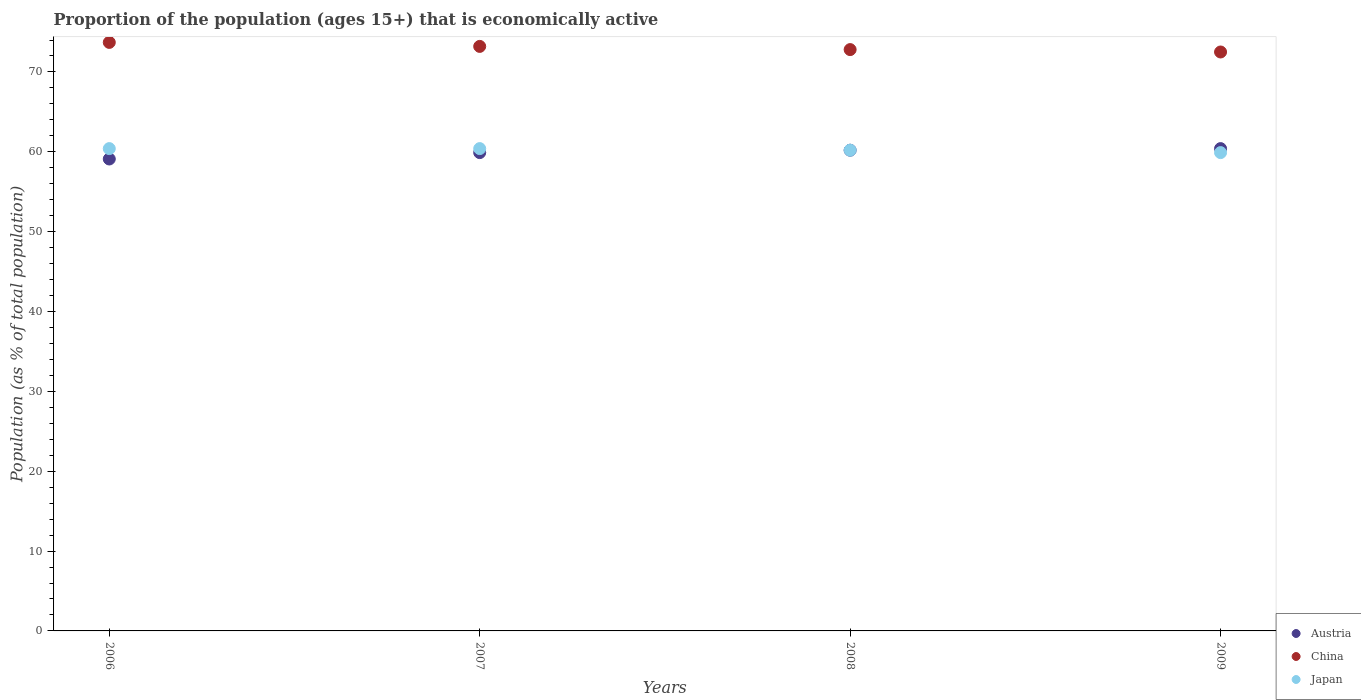Is the number of dotlines equal to the number of legend labels?
Ensure brevity in your answer.  Yes. What is the proportion of the population that is economically active in Austria in 2007?
Ensure brevity in your answer.  59.9. Across all years, what is the maximum proportion of the population that is economically active in Japan?
Provide a short and direct response. 60.4. Across all years, what is the minimum proportion of the population that is economically active in China?
Make the answer very short. 72.5. In which year was the proportion of the population that is economically active in China minimum?
Make the answer very short. 2009. What is the total proportion of the population that is economically active in Japan in the graph?
Your response must be concise. 240.9. What is the difference between the proportion of the population that is economically active in China in 2006 and that in 2009?
Your answer should be very brief. 1.2. What is the difference between the proportion of the population that is economically active in China in 2008 and the proportion of the population that is economically active in Japan in 2007?
Offer a very short reply. 12.4. What is the average proportion of the population that is economically active in Japan per year?
Offer a very short reply. 60.23. In the year 2009, what is the difference between the proportion of the population that is economically active in China and proportion of the population that is economically active in Japan?
Ensure brevity in your answer.  12.6. In how many years, is the proportion of the population that is economically active in China greater than 12 %?
Give a very brief answer. 4. What is the ratio of the proportion of the population that is economically active in Austria in 2008 to that in 2009?
Give a very brief answer. 1. What is the difference between the highest and the second highest proportion of the population that is economically active in China?
Provide a short and direct response. 0.5. In how many years, is the proportion of the population that is economically active in Japan greater than the average proportion of the population that is economically active in Japan taken over all years?
Provide a succinct answer. 2. Is the sum of the proportion of the population that is economically active in Japan in 2008 and 2009 greater than the maximum proportion of the population that is economically active in China across all years?
Provide a short and direct response. Yes. Does the proportion of the population that is economically active in Austria monotonically increase over the years?
Give a very brief answer. Yes. Is the proportion of the population that is economically active in China strictly greater than the proportion of the population that is economically active in Japan over the years?
Keep it short and to the point. Yes. Is the proportion of the population that is economically active in China strictly less than the proportion of the population that is economically active in Austria over the years?
Make the answer very short. No. How many dotlines are there?
Provide a short and direct response. 3. How many years are there in the graph?
Offer a terse response. 4. What is the difference between two consecutive major ticks on the Y-axis?
Make the answer very short. 10. Are the values on the major ticks of Y-axis written in scientific E-notation?
Ensure brevity in your answer.  No. Does the graph contain any zero values?
Keep it short and to the point. No. How are the legend labels stacked?
Your response must be concise. Vertical. What is the title of the graph?
Offer a very short reply. Proportion of the population (ages 15+) that is economically active. What is the label or title of the X-axis?
Offer a very short reply. Years. What is the label or title of the Y-axis?
Ensure brevity in your answer.  Population (as % of total population). What is the Population (as % of total population) in Austria in 2006?
Ensure brevity in your answer.  59.1. What is the Population (as % of total population) in China in 2006?
Make the answer very short. 73.7. What is the Population (as % of total population) in Japan in 2006?
Your answer should be very brief. 60.4. What is the Population (as % of total population) in Austria in 2007?
Your answer should be compact. 59.9. What is the Population (as % of total population) of China in 2007?
Your answer should be very brief. 73.2. What is the Population (as % of total population) in Japan in 2007?
Give a very brief answer. 60.4. What is the Population (as % of total population) in Austria in 2008?
Your answer should be compact. 60.2. What is the Population (as % of total population) in China in 2008?
Keep it short and to the point. 72.8. What is the Population (as % of total population) of Japan in 2008?
Give a very brief answer. 60.2. What is the Population (as % of total population) in Austria in 2009?
Provide a succinct answer. 60.4. What is the Population (as % of total population) in China in 2009?
Provide a short and direct response. 72.5. What is the Population (as % of total population) of Japan in 2009?
Provide a short and direct response. 59.9. Across all years, what is the maximum Population (as % of total population) of Austria?
Keep it short and to the point. 60.4. Across all years, what is the maximum Population (as % of total population) of China?
Your answer should be very brief. 73.7. Across all years, what is the maximum Population (as % of total population) in Japan?
Your response must be concise. 60.4. Across all years, what is the minimum Population (as % of total population) in Austria?
Your answer should be very brief. 59.1. Across all years, what is the minimum Population (as % of total population) in China?
Offer a terse response. 72.5. Across all years, what is the minimum Population (as % of total population) of Japan?
Offer a terse response. 59.9. What is the total Population (as % of total population) of Austria in the graph?
Ensure brevity in your answer.  239.6. What is the total Population (as % of total population) in China in the graph?
Provide a short and direct response. 292.2. What is the total Population (as % of total population) of Japan in the graph?
Make the answer very short. 240.9. What is the difference between the Population (as % of total population) in China in 2006 and that in 2007?
Offer a very short reply. 0.5. What is the difference between the Population (as % of total population) in Japan in 2006 and that in 2009?
Ensure brevity in your answer.  0.5. What is the difference between the Population (as % of total population) of China in 2007 and that in 2008?
Your response must be concise. 0.4. What is the difference between the Population (as % of total population) of Japan in 2007 and that in 2008?
Provide a short and direct response. 0.2. What is the difference between the Population (as % of total population) of Austria in 2007 and that in 2009?
Ensure brevity in your answer.  -0.5. What is the difference between the Population (as % of total population) of Japan in 2007 and that in 2009?
Keep it short and to the point. 0.5. What is the difference between the Population (as % of total population) of Austria in 2006 and the Population (as % of total population) of China in 2007?
Your response must be concise. -14.1. What is the difference between the Population (as % of total population) in Austria in 2006 and the Population (as % of total population) in Japan in 2007?
Give a very brief answer. -1.3. What is the difference between the Population (as % of total population) in Austria in 2006 and the Population (as % of total population) in China in 2008?
Offer a very short reply. -13.7. What is the difference between the Population (as % of total population) in China in 2006 and the Population (as % of total population) in Japan in 2008?
Your answer should be very brief. 13.5. What is the difference between the Population (as % of total population) in Austria in 2006 and the Population (as % of total population) in China in 2009?
Keep it short and to the point. -13.4. What is the difference between the Population (as % of total population) in China in 2006 and the Population (as % of total population) in Japan in 2009?
Make the answer very short. 13.8. What is the difference between the Population (as % of total population) of Austria in 2007 and the Population (as % of total population) of China in 2008?
Ensure brevity in your answer.  -12.9. What is the difference between the Population (as % of total population) in Austria in 2007 and the Population (as % of total population) in Japan in 2008?
Keep it short and to the point. -0.3. What is the difference between the Population (as % of total population) in Austria in 2007 and the Population (as % of total population) in Japan in 2009?
Provide a succinct answer. 0. What is the difference between the Population (as % of total population) in China in 2007 and the Population (as % of total population) in Japan in 2009?
Your response must be concise. 13.3. What is the average Population (as % of total population) in Austria per year?
Ensure brevity in your answer.  59.9. What is the average Population (as % of total population) of China per year?
Your answer should be very brief. 73.05. What is the average Population (as % of total population) of Japan per year?
Give a very brief answer. 60.23. In the year 2006, what is the difference between the Population (as % of total population) of Austria and Population (as % of total population) of China?
Offer a terse response. -14.6. In the year 2008, what is the difference between the Population (as % of total population) of China and Population (as % of total population) of Japan?
Your response must be concise. 12.6. In the year 2009, what is the difference between the Population (as % of total population) of Austria and Population (as % of total population) of China?
Keep it short and to the point. -12.1. In the year 2009, what is the difference between the Population (as % of total population) of Austria and Population (as % of total population) of Japan?
Offer a very short reply. 0.5. In the year 2009, what is the difference between the Population (as % of total population) in China and Population (as % of total population) in Japan?
Keep it short and to the point. 12.6. What is the ratio of the Population (as % of total population) in Austria in 2006 to that in 2007?
Offer a very short reply. 0.99. What is the ratio of the Population (as % of total population) of China in 2006 to that in 2007?
Make the answer very short. 1.01. What is the ratio of the Population (as % of total population) of Austria in 2006 to that in 2008?
Keep it short and to the point. 0.98. What is the ratio of the Population (as % of total population) in China in 2006 to that in 2008?
Give a very brief answer. 1.01. What is the ratio of the Population (as % of total population) in Austria in 2006 to that in 2009?
Give a very brief answer. 0.98. What is the ratio of the Population (as % of total population) in China in 2006 to that in 2009?
Provide a short and direct response. 1.02. What is the ratio of the Population (as % of total population) in Japan in 2006 to that in 2009?
Offer a terse response. 1.01. What is the ratio of the Population (as % of total population) of Austria in 2007 to that in 2008?
Keep it short and to the point. 0.99. What is the ratio of the Population (as % of total population) of China in 2007 to that in 2008?
Give a very brief answer. 1.01. What is the ratio of the Population (as % of total population) in Japan in 2007 to that in 2008?
Provide a succinct answer. 1. What is the ratio of the Population (as % of total population) in Austria in 2007 to that in 2009?
Ensure brevity in your answer.  0.99. What is the ratio of the Population (as % of total population) of China in 2007 to that in 2009?
Give a very brief answer. 1.01. What is the ratio of the Population (as % of total population) in Japan in 2007 to that in 2009?
Provide a succinct answer. 1.01. What is the ratio of the Population (as % of total population) in Austria in 2008 to that in 2009?
Provide a succinct answer. 1. What is the ratio of the Population (as % of total population) of China in 2008 to that in 2009?
Your response must be concise. 1. What is the ratio of the Population (as % of total population) of Japan in 2008 to that in 2009?
Your answer should be very brief. 1. What is the difference between the highest and the second highest Population (as % of total population) in Austria?
Give a very brief answer. 0.2. What is the difference between the highest and the second highest Population (as % of total population) of China?
Provide a succinct answer. 0.5. What is the difference between the highest and the lowest Population (as % of total population) of Austria?
Your answer should be compact. 1.3. What is the difference between the highest and the lowest Population (as % of total population) of China?
Make the answer very short. 1.2. 